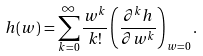Convert formula to latex. <formula><loc_0><loc_0><loc_500><loc_500>h ( w ) = \sum _ { k = 0 } ^ { \infty } \frac { w ^ { k } } { k ! } \left ( \frac { \partial ^ { k } h } { \partial w ^ { k } } \right ) _ { w = 0 } .</formula> 